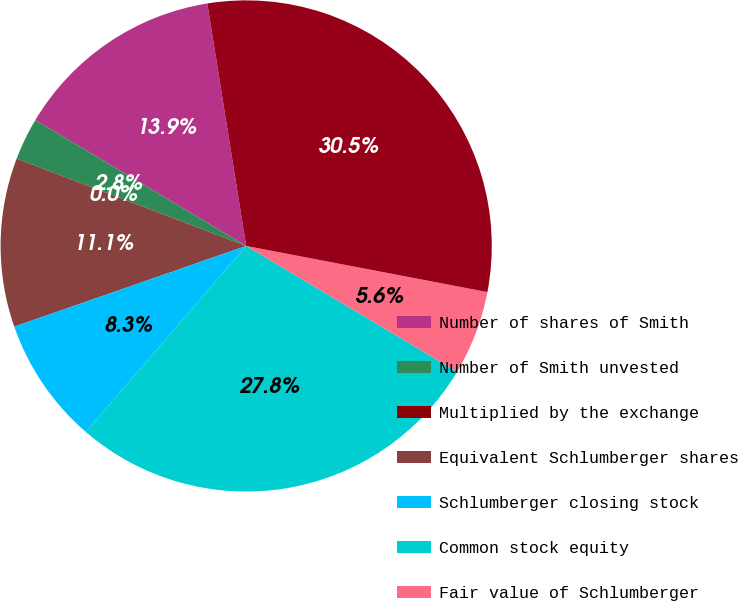Convert chart to OTSL. <chart><loc_0><loc_0><loc_500><loc_500><pie_chart><fcel>Number of shares of Smith<fcel>Number of Smith unvested<fcel>Multiplied by the exchange<fcel>Equivalent Schlumberger shares<fcel>Schlumberger closing stock<fcel>Common stock equity<fcel>Fair value of Schlumberger<fcel>Total fair value of the<nl><fcel>13.9%<fcel>2.78%<fcel>0.0%<fcel>11.12%<fcel>8.34%<fcel>27.76%<fcel>5.56%<fcel>30.54%<nl></chart> 